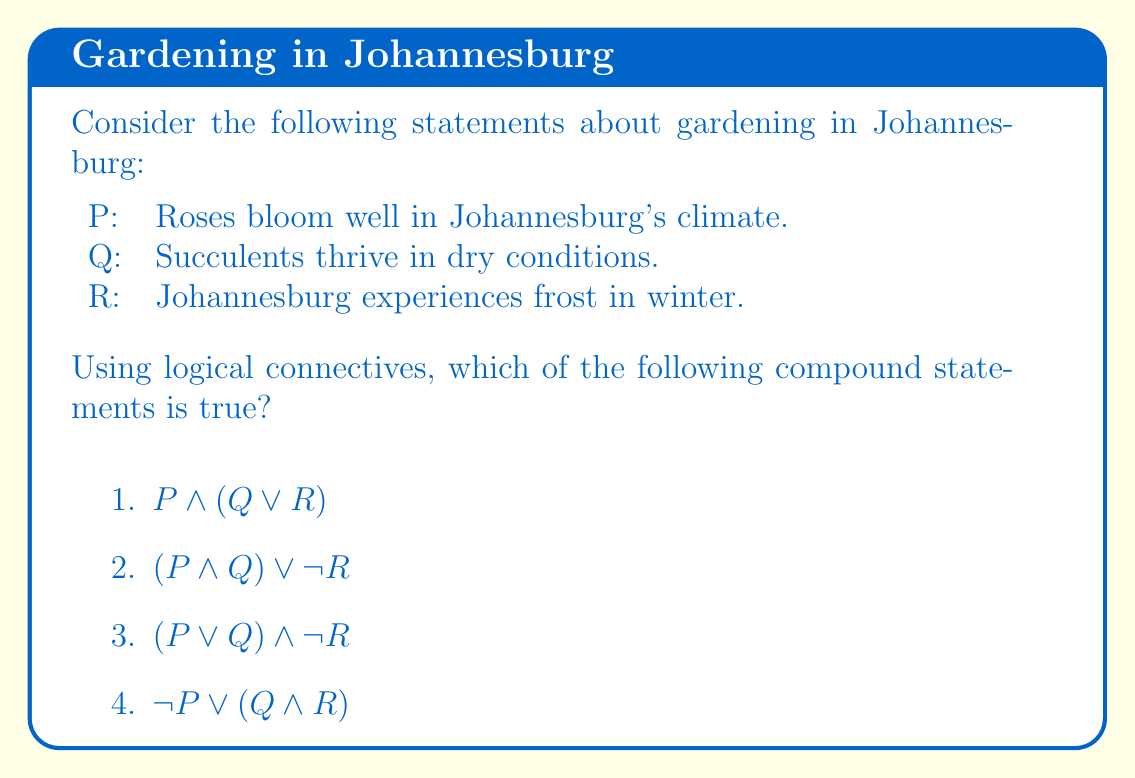Provide a solution to this math problem. Let's evaluate each statement:

1) $P \land (Q \lor R)$
   This means "Roses bloom well in Johannesburg's climate AND (Succulents thrive in dry conditions OR Johannesburg experiences frost in winter)"
   
   P is true: Roses do bloom well in Johannesburg's climate.
   Q is true: Succulents do thrive in dry conditions.
   R is true: Johannesburg does experience frost in winter.
   
   Therefore, $Q \lor R$ is true, and $P \land (Q \lor R)$ is true.

2) $(P \land Q) \lor \neg R$
   This means "(Roses bloom well in Johannesburg's climate AND Succulents thrive in dry conditions) OR (It is not true that Johannesburg experiences frost in winter)"
   
   $P \land Q$ is true, but $\neg R$ is false. However, since we have an OR operator, the whole statement is true.

3) $(P \lor Q) \land \neg R$
   This means "(Roses bloom well in Johannesburg's climate OR Succulents thrive in dry conditions) AND (It is not true that Johannesburg experiences frost in winter)"
   
   $P \lor Q$ is true, but $\neg R$ is false. Since we have an AND operator, the whole statement is false.

4) $\neg P \lor (Q \land R)$
   This means "(It is not true that roses bloom well in Johannesburg's climate) OR (Succulents thrive in dry conditions AND Johannesburg experiences frost in winter)"
   
   $\neg P$ is false, but $Q \land R$ is true. Since we have an OR operator, the whole statement is true.

Therefore, statements 1, 2, and 4 are true, while statement 3 is false.
Answer: 1, 2, and 4 